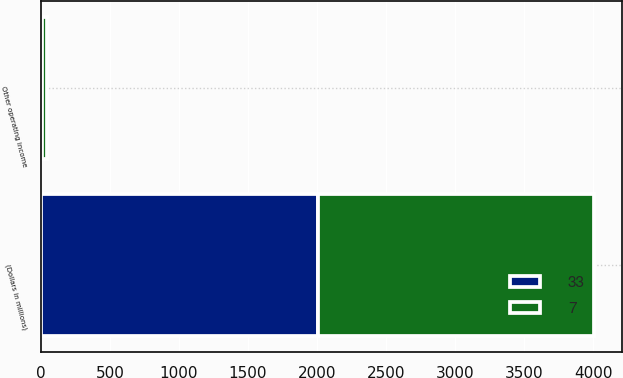<chart> <loc_0><loc_0><loc_500><loc_500><stacked_bar_chart><ecel><fcel>(Dollars in millions)<fcel>Other operating income<nl><fcel>33<fcel>2004<fcel>7<nl><fcel>7<fcel>2003<fcel>33<nl></chart> 